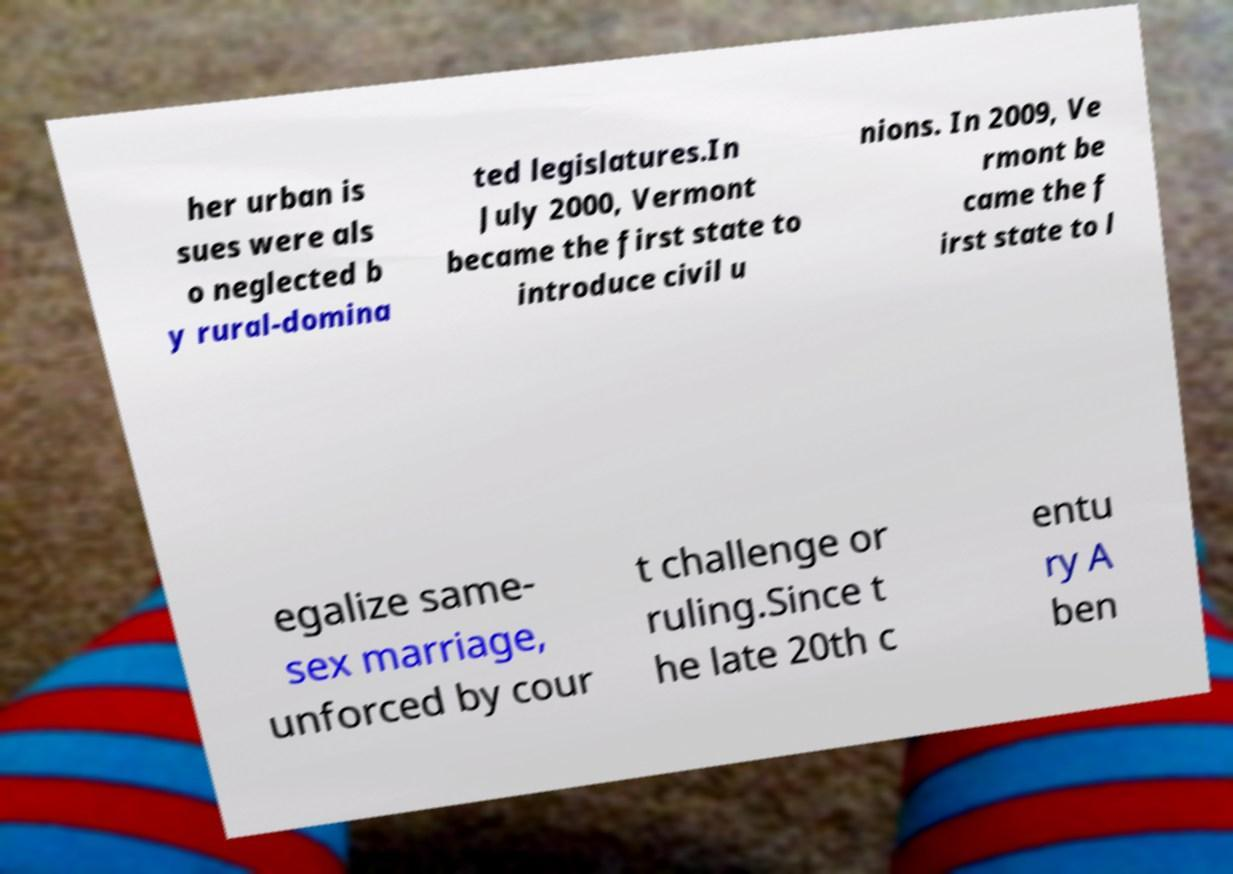Could you assist in decoding the text presented in this image and type it out clearly? her urban is sues were als o neglected b y rural-domina ted legislatures.In July 2000, Vermont became the first state to introduce civil u nions. In 2009, Ve rmont be came the f irst state to l egalize same- sex marriage, unforced by cour t challenge or ruling.Since t he late 20th c entu ry A ben 